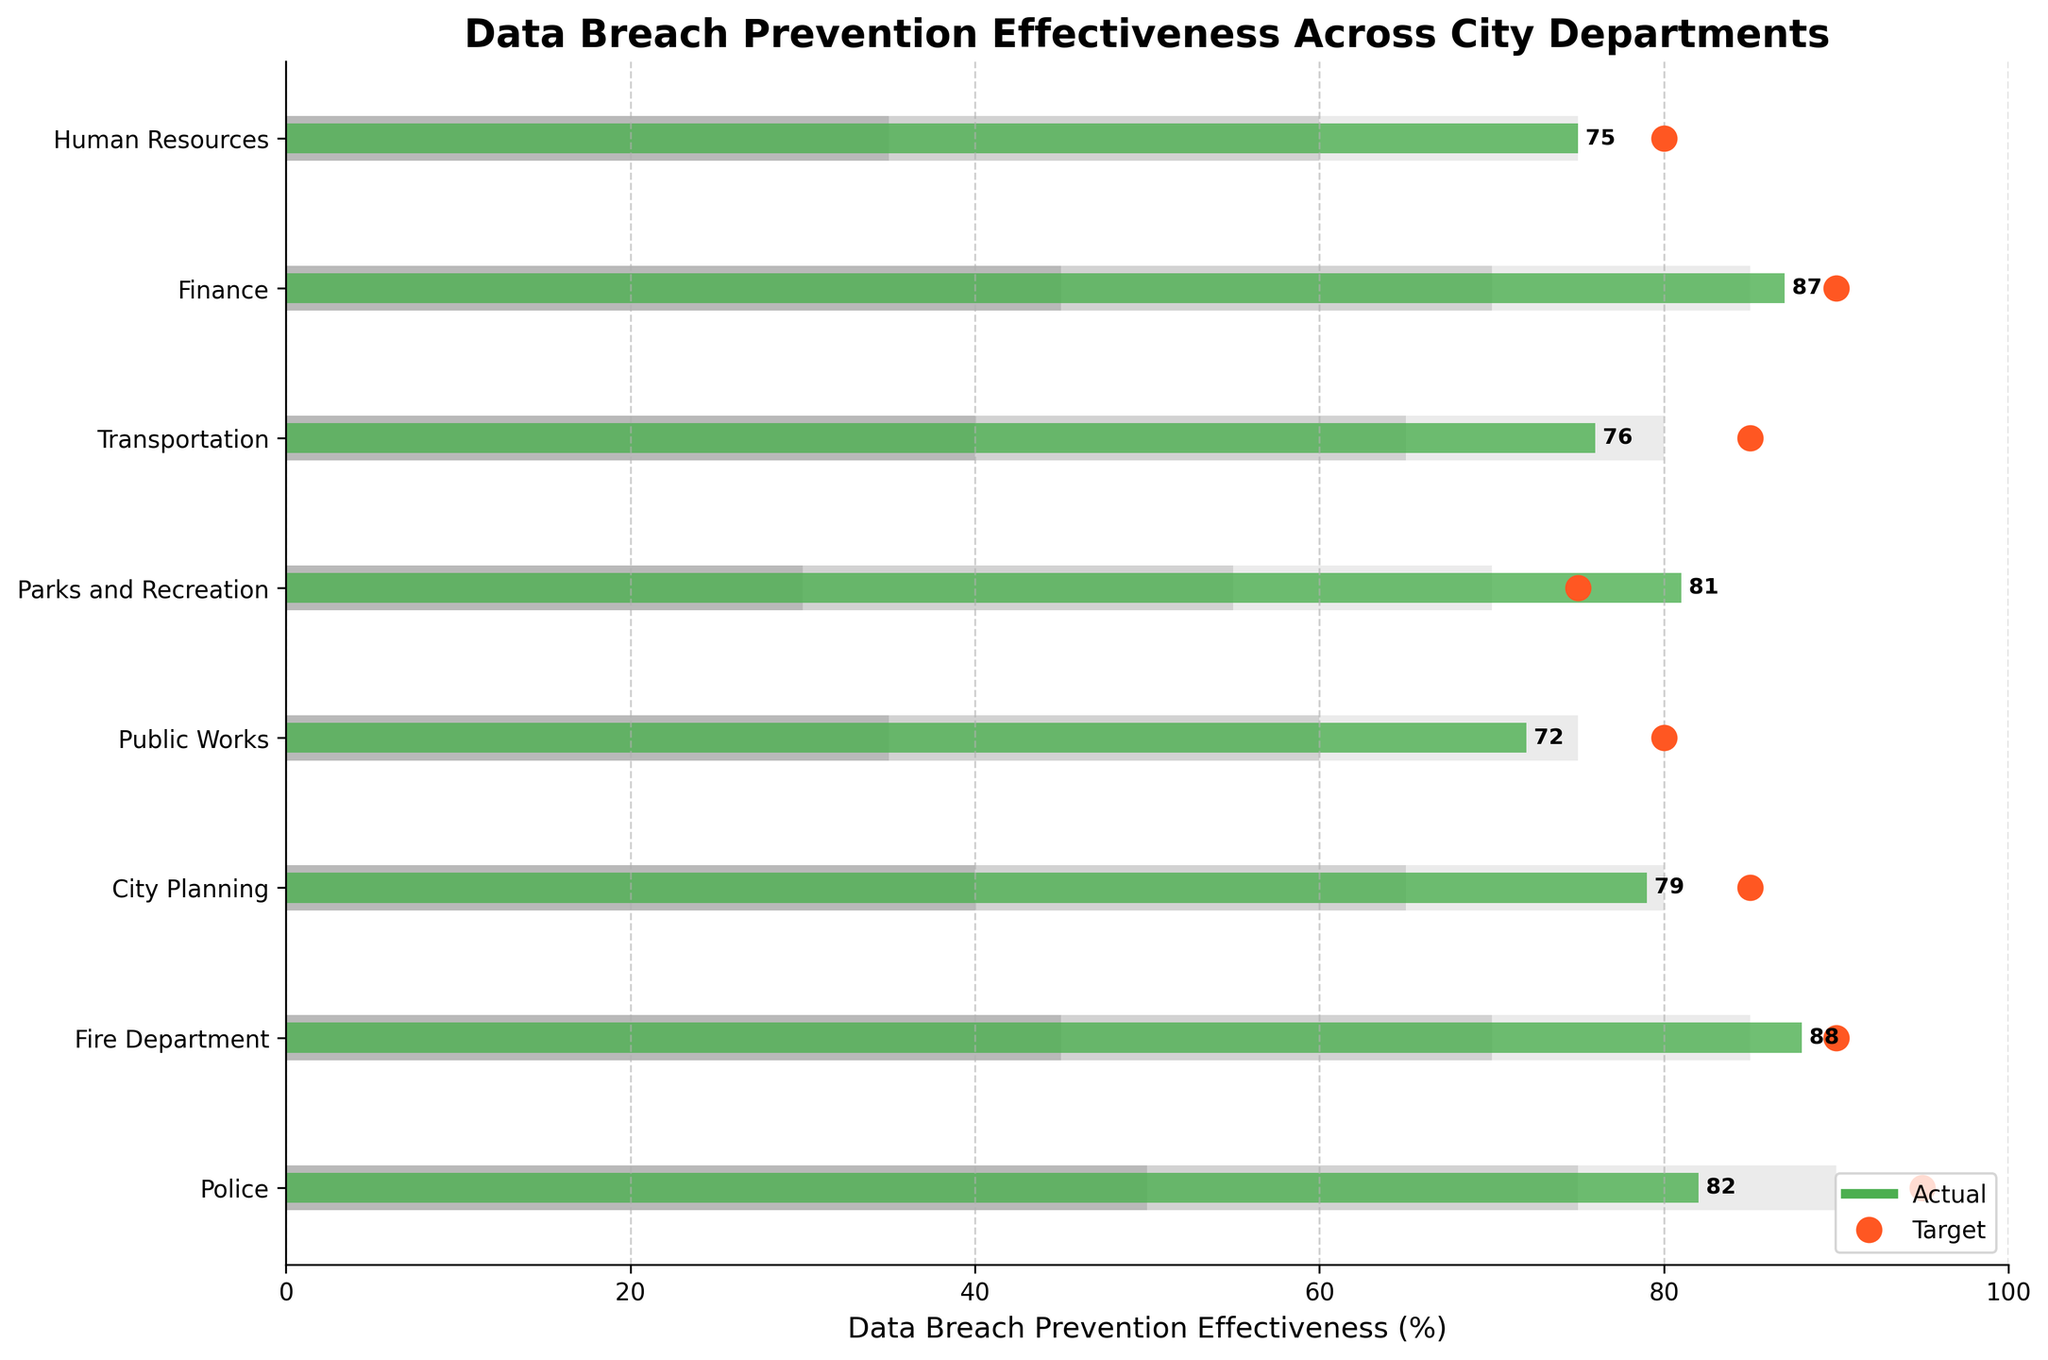How many departments are evaluated in the chart? The chart has each department listed on the y-axis. Counting these, we get 8 departments.
Answer: 8 Which department has the highest actual data breach prevention effectiveness? Looking at the length of the green bars, Parks and Recreation has the highest actual effectiveness which is 81%.
Answer: Parks and Recreation What is the difference between the target and actual effectiveness for the Police department? The target for the Police department is 95%, and the actual effectiveness is 82%. The difference is 95 - 82.
Answer: 13 Which department has the lowest actual effectiveness, and what is its value? By observing the length of the green bars, Public Works has the lowest actual effectiveness at 72%.
Answer: Public Works, 72% Are there any departments that exceeded their target effectiveness? If so, which ones? In the chart, comparing the green bars with the red dots, it shows that Parks and Recreation (81% actual vs 75% target) exceeded their target.
Answer: Parks and Recreation How does the Fire Department's actual effectiveness compare to their target? The target for the Fire Department is 90% and the actual effectiveness is 88%. They fall short of their target by 2%.
Answer: Falls short by 2% Which department has the smallest gap between actual and target effectiveness? By comparing the target and actual values for all departments, we find that Finance (90% target, 87% actual) has the smallest gap of 3%.
Answer: Finance Does the Human Resources department fall within the middle range of effectiveness? The middle range for Human Resources is between 60 and 75. The actual effectiveness for Human Resources is 75, which falls at the top of the middle range.
Answer: Yes What is the average actual effectiveness across all departments? Summing the actual values (82 + 88 + 79 + 72 + 81 + 76 + 87 + 75 = 640) and dividing by the number of departments (8) gives an average of 640/8.
Answer: 80 Which departments have actual effectiveness that falls within the highest range (third range)? The highest range starts from 75 to 100 for most departments. By comparing all actual values, Police (82), Fire Department (88), Parks and Recreation (81), Finance (87), and Human Resources (75) fall within this range.
Answer: Police, Fire Department, Parks and Recreation, Finance, Human Resources 